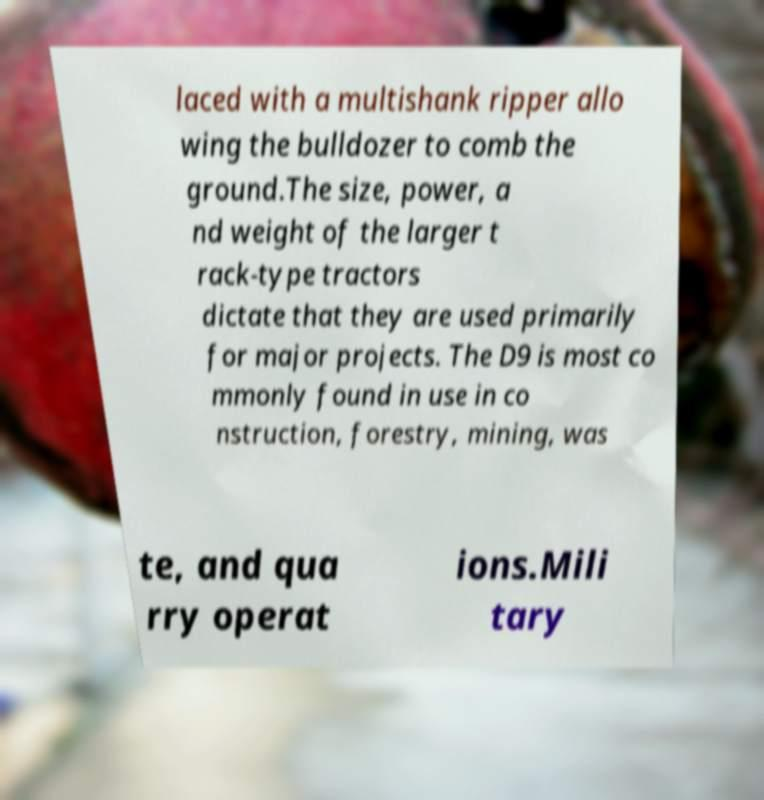Please read and relay the text visible in this image. What does it say? laced with a multishank ripper allo wing the bulldozer to comb the ground.The size, power, a nd weight of the larger t rack-type tractors dictate that they are used primarily for major projects. The D9 is most co mmonly found in use in co nstruction, forestry, mining, was te, and qua rry operat ions.Mili tary 